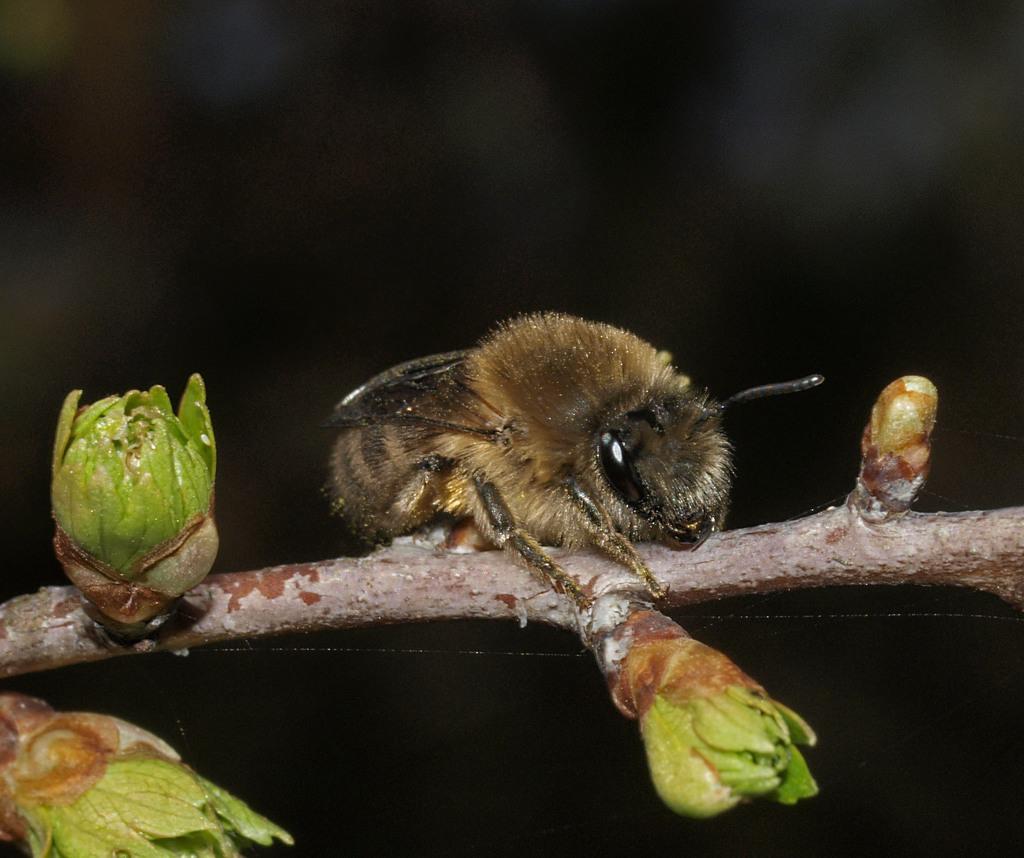How would you summarize this image in a sentence or two? In the center of the image, we can see a bee on the stem and there are some buds and the background is dark. 